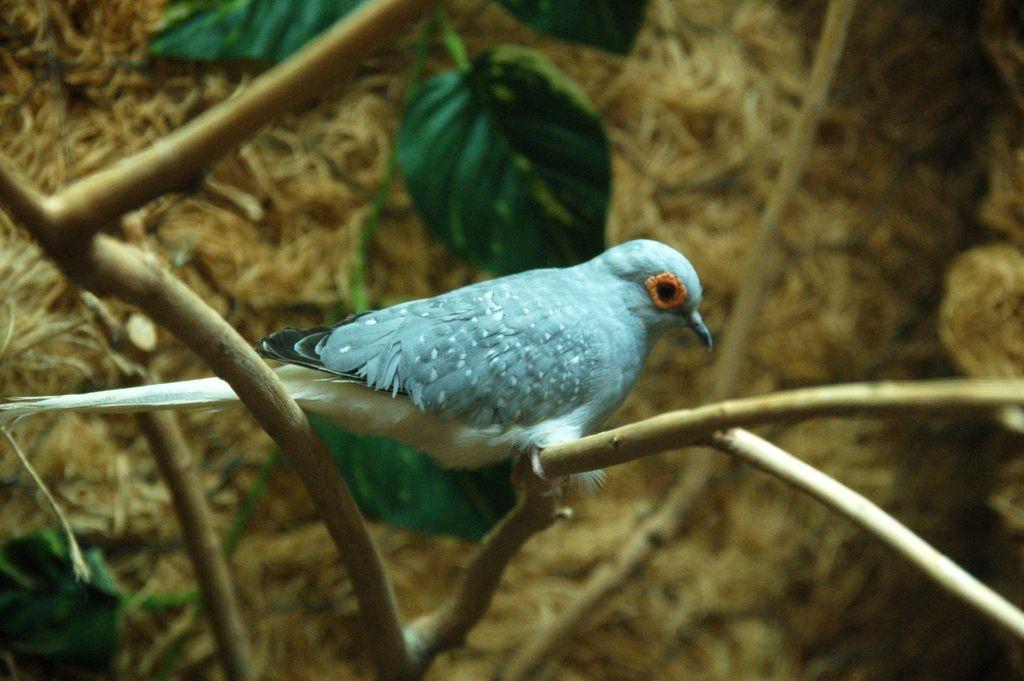How would you summarize this image in a sentence or two? In the image we can see the bird, sitting on the tree branch. Here we can see the leaves and the background is slightly blurred. 